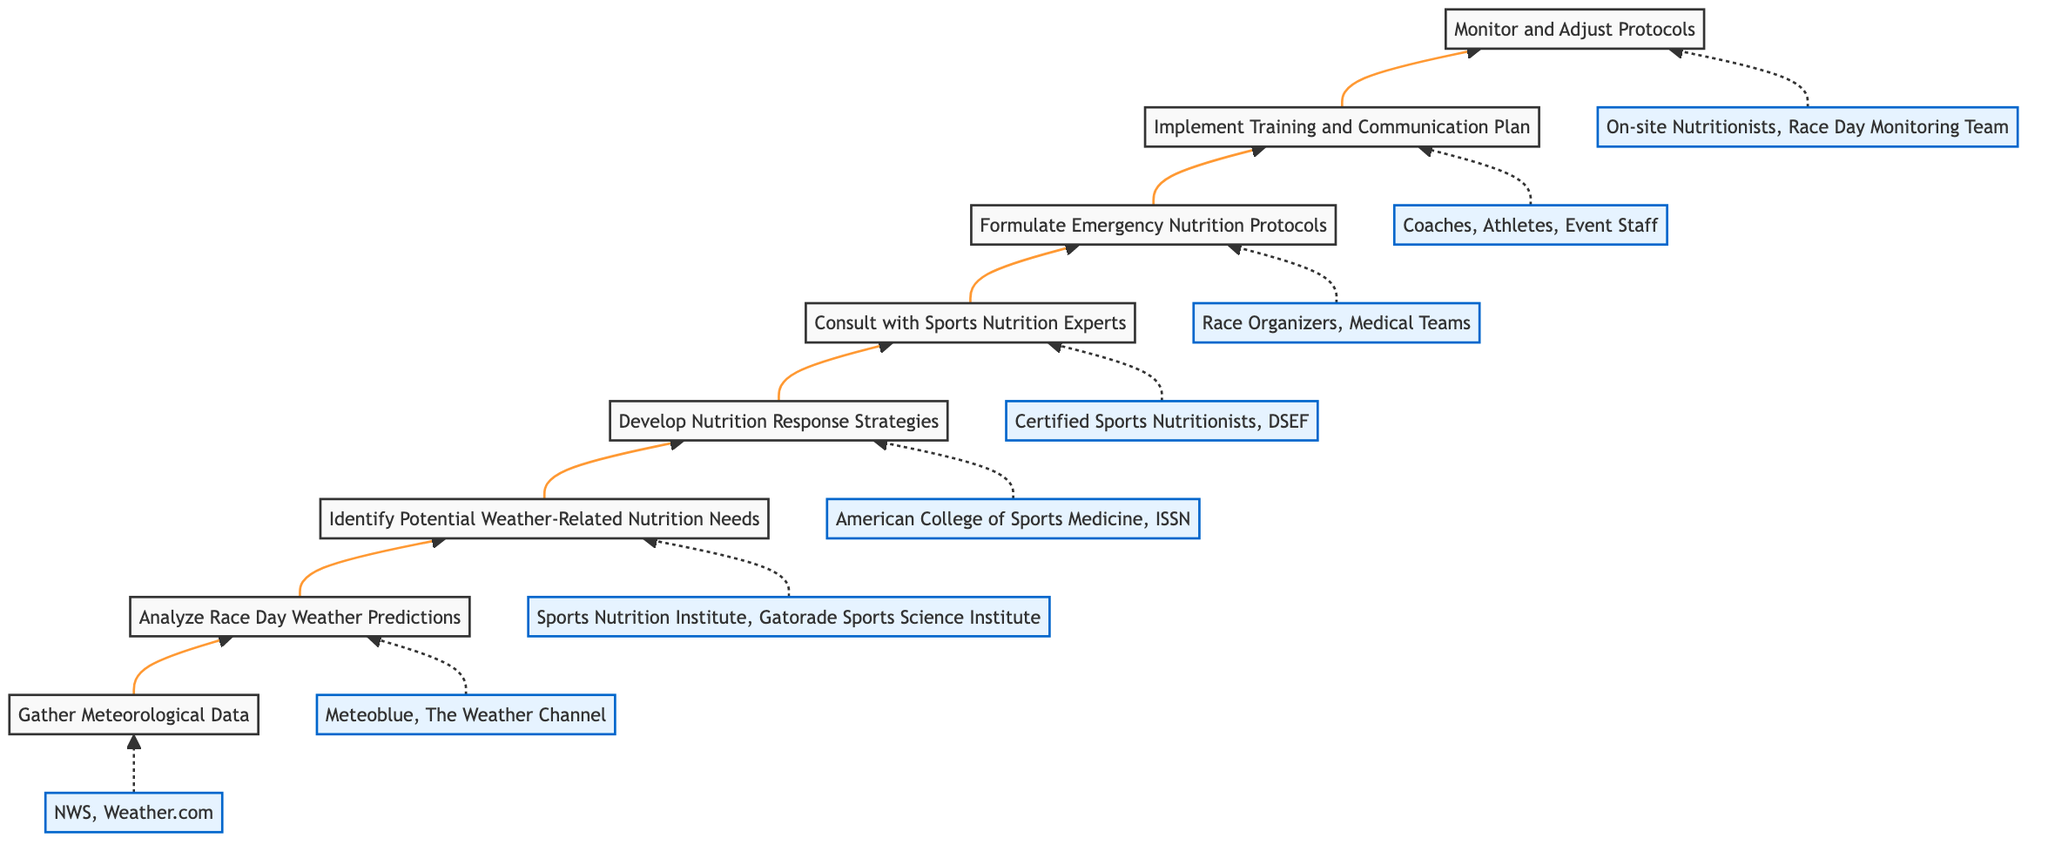What is the first step in the process? The diagram indicates that the first step in the process is "Gather Meteorological Data." This can be found at the bottom of the flowchart as the starting point of the sequence.
Answer: Gather Meteorological Data How many main steps are involved in the emergency nutrition protocols? By counting the distinct nodes connected by arrows in the diagram from bottom to top, there are a total of eight main steps listed.
Answer: Eight Which step comes after "Analyze Race Day Weather Predictions"? Examining the flow of the diagram, the step that follows "Analyze Race Day Weather Predictions" is "Identify Potential Weather-Related Nutrition Needs." This is directly linked and follows logically in the sequence.
Answer: Identify Potential Weather-Related Nutrition Needs What is the last step in the flowchart? The last step in the flowchart, positioned at the top of the diagram, is "Monitor and Adjust Protocols," indicating the final action taken in this process.
Answer: Monitor and Adjust Protocols Which entity is associated with formulating emergency nutrition protocols? According to the diagram, the entity indicated for "Formulate Emergency Nutrition Protocols" is "Race Organizers, Medical Teams." It's shown in a dashed line leading to the corresponding step.
Answer: Race Organizers, Medical Teams What step is directly before "Consult with Sports Nutrition Experts"? Looking at the diagram, the step that comes immediately before "Consult with Sports Nutrition Experts" is "Develop Nutrition Response Strategies," which is directly linked to it in the flow.
Answer: Develop Nutrition Response Strategies Which step focuses on training staff and communication? The step that focuses on training staff and communication is "Implement Training and Communication Plan." This step is designed specifically for this purpose.
Answer: Implement Training and Communication Plan How does the flow of the diagram present the emergency nutrition process? The diagram presents the emergency nutrition process in a bottom-to-top flow, starting with data gathering and building towards the final monitoring and adjustment phase, indicating a sequential progression.
Answer: Bottom to top flow 